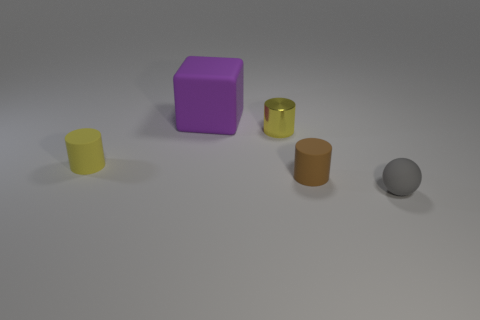Add 3 tiny rubber things. How many objects exist? 8 Subtract all spheres. How many objects are left? 4 Add 3 small yellow metal objects. How many small yellow metal objects exist? 4 Subtract 0 green cylinders. How many objects are left? 5 Subtract all large purple objects. Subtract all large purple rubber cubes. How many objects are left? 3 Add 3 gray things. How many gray things are left? 4 